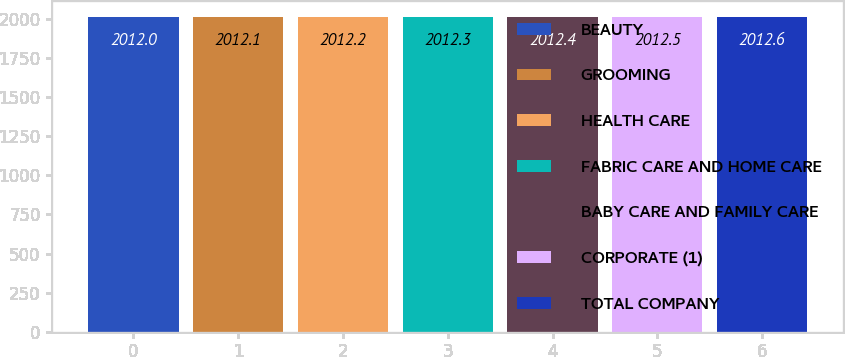Convert chart. <chart><loc_0><loc_0><loc_500><loc_500><bar_chart><fcel>BEAUTY<fcel>GROOMING<fcel>HEALTH CARE<fcel>FABRIC CARE AND HOME CARE<fcel>BABY CARE AND FAMILY CARE<fcel>CORPORATE (1)<fcel>TOTAL COMPANY<nl><fcel>2012<fcel>2012.1<fcel>2012.2<fcel>2012.3<fcel>2012.4<fcel>2012.5<fcel>2012.6<nl></chart> 